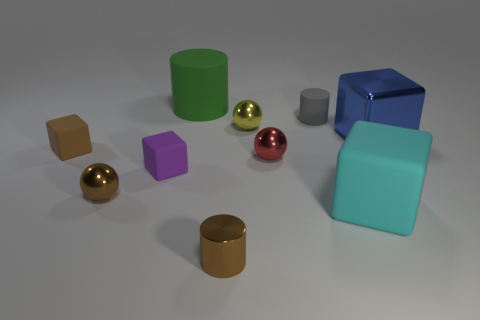The blue object that is the same size as the cyan thing is what shape? cube 